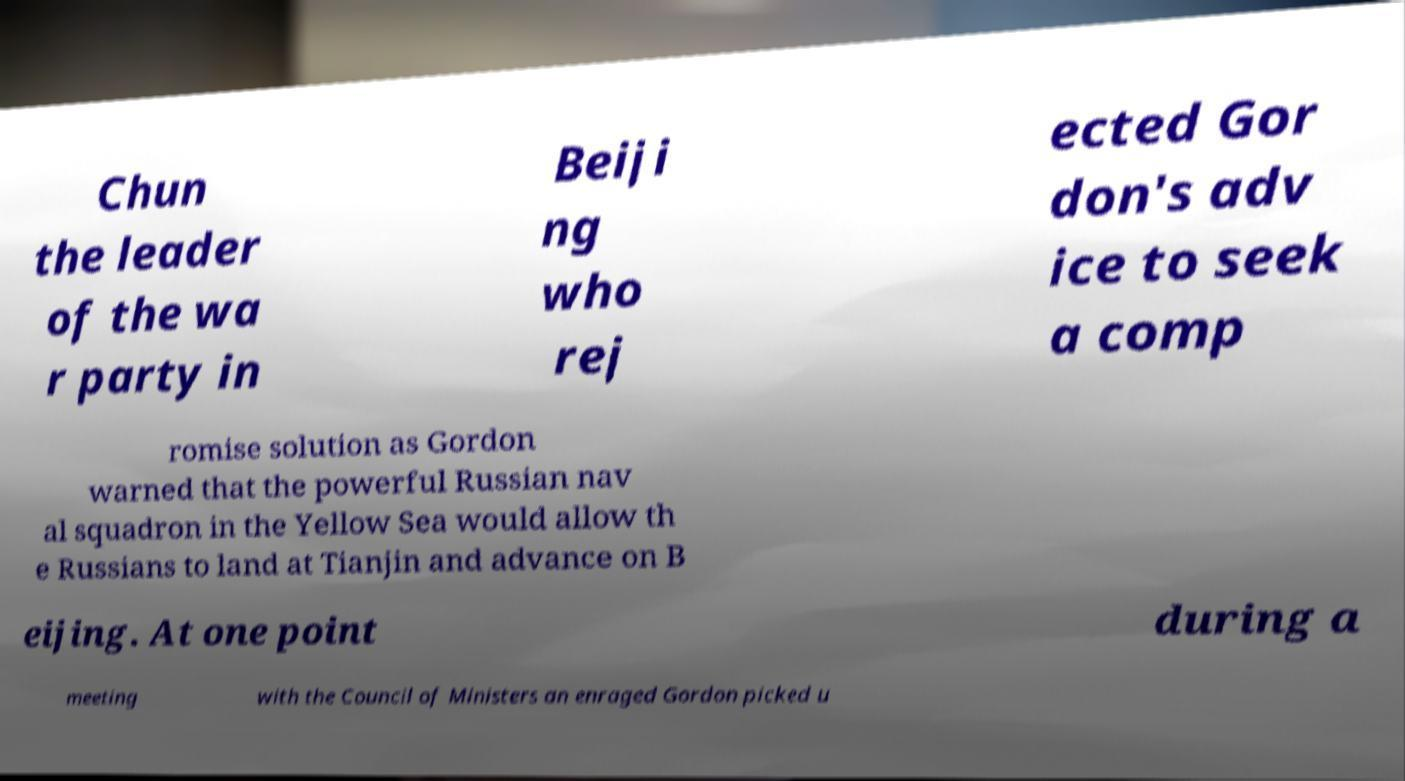For documentation purposes, I need the text within this image transcribed. Could you provide that? Chun the leader of the wa r party in Beiji ng who rej ected Gor don's adv ice to seek a comp romise solution as Gordon warned that the powerful Russian nav al squadron in the Yellow Sea would allow th e Russians to land at Tianjin and advance on B eijing. At one point during a meeting with the Council of Ministers an enraged Gordon picked u 